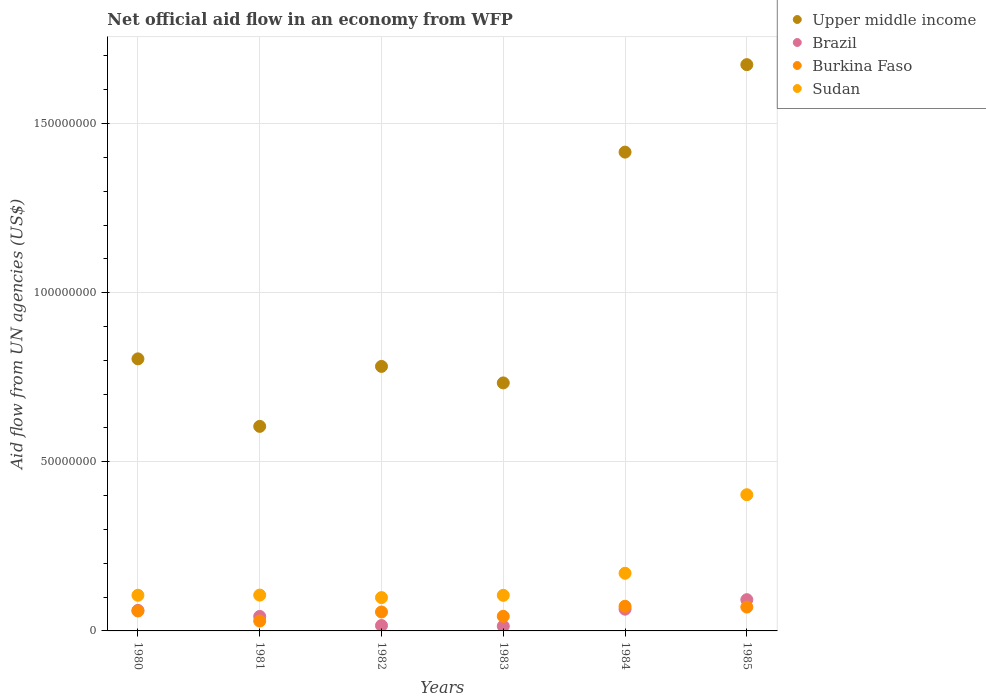How many different coloured dotlines are there?
Provide a short and direct response. 4. What is the net official aid flow in Burkina Faso in 1983?
Provide a short and direct response. 4.32e+06. Across all years, what is the maximum net official aid flow in Brazil?
Give a very brief answer. 9.24e+06. Across all years, what is the minimum net official aid flow in Upper middle income?
Your answer should be compact. 6.05e+07. In which year was the net official aid flow in Sudan maximum?
Your answer should be compact. 1985. In which year was the net official aid flow in Sudan minimum?
Offer a terse response. 1982. What is the total net official aid flow in Brazil in the graph?
Ensure brevity in your answer.  2.90e+07. What is the difference between the net official aid flow in Brazil in 1983 and that in 1984?
Provide a short and direct response. -5.03e+06. What is the difference between the net official aid flow in Burkina Faso in 1983 and the net official aid flow in Sudan in 1982?
Your response must be concise. -5.53e+06. What is the average net official aid flow in Upper middle income per year?
Make the answer very short. 1.00e+08. In the year 1985, what is the difference between the net official aid flow in Sudan and net official aid flow in Upper middle income?
Make the answer very short. -1.27e+08. In how many years, is the net official aid flow in Upper middle income greater than 30000000 US$?
Your response must be concise. 6. What is the ratio of the net official aid flow in Burkina Faso in 1981 to that in 1982?
Make the answer very short. 0.52. Is the net official aid flow in Upper middle income in 1983 less than that in 1984?
Offer a very short reply. Yes. What is the difference between the highest and the second highest net official aid flow in Upper middle income?
Offer a very short reply. 2.59e+07. What is the difference between the highest and the lowest net official aid flow in Brazil?
Your answer should be very brief. 7.84e+06. In how many years, is the net official aid flow in Upper middle income greater than the average net official aid flow in Upper middle income taken over all years?
Offer a very short reply. 2. How many dotlines are there?
Your answer should be very brief. 4. Are the values on the major ticks of Y-axis written in scientific E-notation?
Provide a succinct answer. No. Does the graph contain grids?
Make the answer very short. Yes. Where does the legend appear in the graph?
Offer a terse response. Top right. How many legend labels are there?
Give a very brief answer. 4. What is the title of the graph?
Keep it short and to the point. Net official aid flow in an economy from WFP. What is the label or title of the Y-axis?
Ensure brevity in your answer.  Aid flow from UN agencies (US$). What is the Aid flow from UN agencies (US$) in Upper middle income in 1980?
Your answer should be very brief. 8.04e+07. What is the Aid flow from UN agencies (US$) in Brazil in 1980?
Make the answer very short. 6.06e+06. What is the Aid flow from UN agencies (US$) in Burkina Faso in 1980?
Your answer should be very brief. 5.90e+06. What is the Aid flow from UN agencies (US$) of Sudan in 1980?
Offer a terse response. 1.05e+07. What is the Aid flow from UN agencies (US$) of Upper middle income in 1981?
Provide a short and direct response. 6.05e+07. What is the Aid flow from UN agencies (US$) in Brazil in 1981?
Ensure brevity in your answer.  4.28e+06. What is the Aid flow from UN agencies (US$) in Burkina Faso in 1981?
Provide a succinct answer. 2.92e+06. What is the Aid flow from UN agencies (US$) of Sudan in 1981?
Your answer should be very brief. 1.06e+07. What is the Aid flow from UN agencies (US$) in Upper middle income in 1982?
Make the answer very short. 7.82e+07. What is the Aid flow from UN agencies (US$) in Brazil in 1982?
Make the answer very short. 1.59e+06. What is the Aid flow from UN agencies (US$) of Burkina Faso in 1982?
Your answer should be compact. 5.60e+06. What is the Aid flow from UN agencies (US$) in Sudan in 1982?
Ensure brevity in your answer.  9.85e+06. What is the Aid flow from UN agencies (US$) of Upper middle income in 1983?
Your response must be concise. 7.33e+07. What is the Aid flow from UN agencies (US$) in Brazil in 1983?
Provide a short and direct response. 1.40e+06. What is the Aid flow from UN agencies (US$) in Burkina Faso in 1983?
Provide a short and direct response. 4.32e+06. What is the Aid flow from UN agencies (US$) of Sudan in 1983?
Provide a short and direct response. 1.05e+07. What is the Aid flow from UN agencies (US$) of Upper middle income in 1984?
Give a very brief answer. 1.42e+08. What is the Aid flow from UN agencies (US$) of Brazil in 1984?
Give a very brief answer. 6.43e+06. What is the Aid flow from UN agencies (US$) of Burkina Faso in 1984?
Offer a very short reply. 7.29e+06. What is the Aid flow from UN agencies (US$) of Sudan in 1984?
Your answer should be very brief. 1.70e+07. What is the Aid flow from UN agencies (US$) in Upper middle income in 1985?
Make the answer very short. 1.67e+08. What is the Aid flow from UN agencies (US$) in Brazil in 1985?
Offer a terse response. 9.24e+06. What is the Aid flow from UN agencies (US$) of Burkina Faso in 1985?
Offer a very short reply. 7.06e+06. What is the Aid flow from UN agencies (US$) of Sudan in 1985?
Your answer should be very brief. 4.03e+07. Across all years, what is the maximum Aid flow from UN agencies (US$) of Upper middle income?
Make the answer very short. 1.67e+08. Across all years, what is the maximum Aid flow from UN agencies (US$) of Brazil?
Your answer should be compact. 9.24e+06. Across all years, what is the maximum Aid flow from UN agencies (US$) in Burkina Faso?
Your response must be concise. 7.29e+06. Across all years, what is the maximum Aid flow from UN agencies (US$) of Sudan?
Provide a short and direct response. 4.03e+07. Across all years, what is the minimum Aid flow from UN agencies (US$) of Upper middle income?
Give a very brief answer. 6.05e+07. Across all years, what is the minimum Aid flow from UN agencies (US$) of Brazil?
Provide a short and direct response. 1.40e+06. Across all years, what is the minimum Aid flow from UN agencies (US$) of Burkina Faso?
Offer a terse response. 2.92e+06. Across all years, what is the minimum Aid flow from UN agencies (US$) in Sudan?
Your response must be concise. 9.85e+06. What is the total Aid flow from UN agencies (US$) in Upper middle income in the graph?
Your answer should be compact. 6.01e+08. What is the total Aid flow from UN agencies (US$) in Brazil in the graph?
Your response must be concise. 2.90e+07. What is the total Aid flow from UN agencies (US$) in Burkina Faso in the graph?
Your answer should be compact. 3.31e+07. What is the total Aid flow from UN agencies (US$) in Sudan in the graph?
Make the answer very short. 9.88e+07. What is the difference between the Aid flow from UN agencies (US$) in Upper middle income in 1980 and that in 1981?
Make the answer very short. 2.00e+07. What is the difference between the Aid flow from UN agencies (US$) in Brazil in 1980 and that in 1981?
Keep it short and to the point. 1.78e+06. What is the difference between the Aid flow from UN agencies (US$) of Burkina Faso in 1980 and that in 1981?
Provide a succinct answer. 2.98e+06. What is the difference between the Aid flow from UN agencies (US$) in Sudan in 1980 and that in 1981?
Your answer should be very brief. -5.00e+04. What is the difference between the Aid flow from UN agencies (US$) in Upper middle income in 1980 and that in 1982?
Keep it short and to the point. 2.23e+06. What is the difference between the Aid flow from UN agencies (US$) of Brazil in 1980 and that in 1982?
Give a very brief answer. 4.47e+06. What is the difference between the Aid flow from UN agencies (US$) of Sudan in 1980 and that in 1982?
Provide a short and direct response. 6.90e+05. What is the difference between the Aid flow from UN agencies (US$) in Upper middle income in 1980 and that in 1983?
Keep it short and to the point. 7.11e+06. What is the difference between the Aid flow from UN agencies (US$) in Brazil in 1980 and that in 1983?
Offer a terse response. 4.66e+06. What is the difference between the Aid flow from UN agencies (US$) of Burkina Faso in 1980 and that in 1983?
Give a very brief answer. 1.58e+06. What is the difference between the Aid flow from UN agencies (US$) in Sudan in 1980 and that in 1983?
Your answer should be compact. 2.00e+04. What is the difference between the Aid flow from UN agencies (US$) of Upper middle income in 1980 and that in 1984?
Your answer should be very brief. -6.11e+07. What is the difference between the Aid flow from UN agencies (US$) of Brazil in 1980 and that in 1984?
Keep it short and to the point. -3.70e+05. What is the difference between the Aid flow from UN agencies (US$) of Burkina Faso in 1980 and that in 1984?
Keep it short and to the point. -1.39e+06. What is the difference between the Aid flow from UN agencies (US$) of Sudan in 1980 and that in 1984?
Your answer should be compact. -6.51e+06. What is the difference between the Aid flow from UN agencies (US$) of Upper middle income in 1980 and that in 1985?
Ensure brevity in your answer.  -8.70e+07. What is the difference between the Aid flow from UN agencies (US$) of Brazil in 1980 and that in 1985?
Provide a succinct answer. -3.18e+06. What is the difference between the Aid flow from UN agencies (US$) in Burkina Faso in 1980 and that in 1985?
Your response must be concise. -1.16e+06. What is the difference between the Aid flow from UN agencies (US$) of Sudan in 1980 and that in 1985?
Provide a short and direct response. -2.97e+07. What is the difference between the Aid flow from UN agencies (US$) in Upper middle income in 1981 and that in 1982?
Your answer should be compact. -1.77e+07. What is the difference between the Aid flow from UN agencies (US$) of Brazil in 1981 and that in 1982?
Your answer should be very brief. 2.69e+06. What is the difference between the Aid flow from UN agencies (US$) of Burkina Faso in 1981 and that in 1982?
Offer a very short reply. -2.68e+06. What is the difference between the Aid flow from UN agencies (US$) in Sudan in 1981 and that in 1982?
Offer a terse response. 7.40e+05. What is the difference between the Aid flow from UN agencies (US$) of Upper middle income in 1981 and that in 1983?
Provide a short and direct response. -1.28e+07. What is the difference between the Aid flow from UN agencies (US$) of Brazil in 1981 and that in 1983?
Your answer should be compact. 2.88e+06. What is the difference between the Aid flow from UN agencies (US$) in Burkina Faso in 1981 and that in 1983?
Ensure brevity in your answer.  -1.40e+06. What is the difference between the Aid flow from UN agencies (US$) of Sudan in 1981 and that in 1983?
Your response must be concise. 7.00e+04. What is the difference between the Aid flow from UN agencies (US$) of Upper middle income in 1981 and that in 1984?
Offer a very short reply. -8.11e+07. What is the difference between the Aid flow from UN agencies (US$) in Brazil in 1981 and that in 1984?
Your answer should be very brief. -2.15e+06. What is the difference between the Aid flow from UN agencies (US$) in Burkina Faso in 1981 and that in 1984?
Provide a succinct answer. -4.37e+06. What is the difference between the Aid flow from UN agencies (US$) in Sudan in 1981 and that in 1984?
Your answer should be compact. -6.46e+06. What is the difference between the Aid flow from UN agencies (US$) of Upper middle income in 1981 and that in 1985?
Make the answer very short. -1.07e+08. What is the difference between the Aid flow from UN agencies (US$) in Brazil in 1981 and that in 1985?
Give a very brief answer. -4.96e+06. What is the difference between the Aid flow from UN agencies (US$) in Burkina Faso in 1981 and that in 1985?
Make the answer very short. -4.14e+06. What is the difference between the Aid flow from UN agencies (US$) in Sudan in 1981 and that in 1985?
Give a very brief answer. -2.97e+07. What is the difference between the Aid flow from UN agencies (US$) in Upper middle income in 1982 and that in 1983?
Provide a short and direct response. 4.88e+06. What is the difference between the Aid flow from UN agencies (US$) in Burkina Faso in 1982 and that in 1983?
Provide a succinct answer. 1.28e+06. What is the difference between the Aid flow from UN agencies (US$) in Sudan in 1982 and that in 1983?
Provide a short and direct response. -6.70e+05. What is the difference between the Aid flow from UN agencies (US$) of Upper middle income in 1982 and that in 1984?
Ensure brevity in your answer.  -6.34e+07. What is the difference between the Aid flow from UN agencies (US$) in Brazil in 1982 and that in 1984?
Provide a short and direct response. -4.84e+06. What is the difference between the Aid flow from UN agencies (US$) of Burkina Faso in 1982 and that in 1984?
Your answer should be compact. -1.69e+06. What is the difference between the Aid flow from UN agencies (US$) in Sudan in 1982 and that in 1984?
Ensure brevity in your answer.  -7.20e+06. What is the difference between the Aid flow from UN agencies (US$) in Upper middle income in 1982 and that in 1985?
Provide a succinct answer. -8.92e+07. What is the difference between the Aid flow from UN agencies (US$) of Brazil in 1982 and that in 1985?
Your answer should be very brief. -7.65e+06. What is the difference between the Aid flow from UN agencies (US$) of Burkina Faso in 1982 and that in 1985?
Provide a short and direct response. -1.46e+06. What is the difference between the Aid flow from UN agencies (US$) of Sudan in 1982 and that in 1985?
Your answer should be compact. -3.04e+07. What is the difference between the Aid flow from UN agencies (US$) in Upper middle income in 1983 and that in 1984?
Keep it short and to the point. -6.82e+07. What is the difference between the Aid flow from UN agencies (US$) in Brazil in 1983 and that in 1984?
Offer a very short reply. -5.03e+06. What is the difference between the Aid flow from UN agencies (US$) in Burkina Faso in 1983 and that in 1984?
Offer a terse response. -2.97e+06. What is the difference between the Aid flow from UN agencies (US$) in Sudan in 1983 and that in 1984?
Ensure brevity in your answer.  -6.53e+06. What is the difference between the Aid flow from UN agencies (US$) of Upper middle income in 1983 and that in 1985?
Give a very brief answer. -9.41e+07. What is the difference between the Aid flow from UN agencies (US$) in Brazil in 1983 and that in 1985?
Offer a very short reply. -7.84e+06. What is the difference between the Aid flow from UN agencies (US$) in Burkina Faso in 1983 and that in 1985?
Your answer should be compact. -2.74e+06. What is the difference between the Aid flow from UN agencies (US$) in Sudan in 1983 and that in 1985?
Keep it short and to the point. -2.98e+07. What is the difference between the Aid flow from UN agencies (US$) in Upper middle income in 1984 and that in 1985?
Provide a short and direct response. -2.59e+07. What is the difference between the Aid flow from UN agencies (US$) of Brazil in 1984 and that in 1985?
Offer a terse response. -2.81e+06. What is the difference between the Aid flow from UN agencies (US$) in Burkina Faso in 1984 and that in 1985?
Offer a very short reply. 2.30e+05. What is the difference between the Aid flow from UN agencies (US$) in Sudan in 1984 and that in 1985?
Keep it short and to the point. -2.32e+07. What is the difference between the Aid flow from UN agencies (US$) of Upper middle income in 1980 and the Aid flow from UN agencies (US$) of Brazil in 1981?
Provide a short and direct response. 7.62e+07. What is the difference between the Aid flow from UN agencies (US$) in Upper middle income in 1980 and the Aid flow from UN agencies (US$) in Burkina Faso in 1981?
Your response must be concise. 7.75e+07. What is the difference between the Aid flow from UN agencies (US$) of Upper middle income in 1980 and the Aid flow from UN agencies (US$) of Sudan in 1981?
Ensure brevity in your answer.  6.98e+07. What is the difference between the Aid flow from UN agencies (US$) of Brazil in 1980 and the Aid flow from UN agencies (US$) of Burkina Faso in 1981?
Your answer should be compact. 3.14e+06. What is the difference between the Aid flow from UN agencies (US$) in Brazil in 1980 and the Aid flow from UN agencies (US$) in Sudan in 1981?
Your answer should be compact. -4.53e+06. What is the difference between the Aid flow from UN agencies (US$) in Burkina Faso in 1980 and the Aid flow from UN agencies (US$) in Sudan in 1981?
Your answer should be compact. -4.69e+06. What is the difference between the Aid flow from UN agencies (US$) in Upper middle income in 1980 and the Aid flow from UN agencies (US$) in Brazil in 1982?
Offer a terse response. 7.88e+07. What is the difference between the Aid flow from UN agencies (US$) of Upper middle income in 1980 and the Aid flow from UN agencies (US$) of Burkina Faso in 1982?
Give a very brief answer. 7.48e+07. What is the difference between the Aid flow from UN agencies (US$) in Upper middle income in 1980 and the Aid flow from UN agencies (US$) in Sudan in 1982?
Make the answer very short. 7.06e+07. What is the difference between the Aid flow from UN agencies (US$) of Brazil in 1980 and the Aid flow from UN agencies (US$) of Sudan in 1982?
Your response must be concise. -3.79e+06. What is the difference between the Aid flow from UN agencies (US$) of Burkina Faso in 1980 and the Aid flow from UN agencies (US$) of Sudan in 1982?
Your answer should be very brief. -3.95e+06. What is the difference between the Aid flow from UN agencies (US$) of Upper middle income in 1980 and the Aid flow from UN agencies (US$) of Brazil in 1983?
Your answer should be compact. 7.90e+07. What is the difference between the Aid flow from UN agencies (US$) in Upper middle income in 1980 and the Aid flow from UN agencies (US$) in Burkina Faso in 1983?
Provide a short and direct response. 7.61e+07. What is the difference between the Aid flow from UN agencies (US$) of Upper middle income in 1980 and the Aid flow from UN agencies (US$) of Sudan in 1983?
Your response must be concise. 6.99e+07. What is the difference between the Aid flow from UN agencies (US$) of Brazil in 1980 and the Aid flow from UN agencies (US$) of Burkina Faso in 1983?
Provide a succinct answer. 1.74e+06. What is the difference between the Aid flow from UN agencies (US$) in Brazil in 1980 and the Aid flow from UN agencies (US$) in Sudan in 1983?
Your answer should be very brief. -4.46e+06. What is the difference between the Aid flow from UN agencies (US$) in Burkina Faso in 1980 and the Aid flow from UN agencies (US$) in Sudan in 1983?
Make the answer very short. -4.62e+06. What is the difference between the Aid flow from UN agencies (US$) of Upper middle income in 1980 and the Aid flow from UN agencies (US$) of Brazil in 1984?
Offer a very short reply. 7.40e+07. What is the difference between the Aid flow from UN agencies (US$) in Upper middle income in 1980 and the Aid flow from UN agencies (US$) in Burkina Faso in 1984?
Make the answer very short. 7.32e+07. What is the difference between the Aid flow from UN agencies (US$) in Upper middle income in 1980 and the Aid flow from UN agencies (US$) in Sudan in 1984?
Keep it short and to the point. 6.34e+07. What is the difference between the Aid flow from UN agencies (US$) of Brazil in 1980 and the Aid flow from UN agencies (US$) of Burkina Faso in 1984?
Give a very brief answer. -1.23e+06. What is the difference between the Aid flow from UN agencies (US$) of Brazil in 1980 and the Aid flow from UN agencies (US$) of Sudan in 1984?
Provide a short and direct response. -1.10e+07. What is the difference between the Aid flow from UN agencies (US$) in Burkina Faso in 1980 and the Aid flow from UN agencies (US$) in Sudan in 1984?
Ensure brevity in your answer.  -1.12e+07. What is the difference between the Aid flow from UN agencies (US$) of Upper middle income in 1980 and the Aid flow from UN agencies (US$) of Brazil in 1985?
Your response must be concise. 7.12e+07. What is the difference between the Aid flow from UN agencies (US$) in Upper middle income in 1980 and the Aid flow from UN agencies (US$) in Burkina Faso in 1985?
Your response must be concise. 7.34e+07. What is the difference between the Aid flow from UN agencies (US$) of Upper middle income in 1980 and the Aid flow from UN agencies (US$) of Sudan in 1985?
Offer a very short reply. 4.02e+07. What is the difference between the Aid flow from UN agencies (US$) in Brazil in 1980 and the Aid flow from UN agencies (US$) in Sudan in 1985?
Ensure brevity in your answer.  -3.42e+07. What is the difference between the Aid flow from UN agencies (US$) of Burkina Faso in 1980 and the Aid flow from UN agencies (US$) of Sudan in 1985?
Your answer should be compact. -3.44e+07. What is the difference between the Aid flow from UN agencies (US$) of Upper middle income in 1981 and the Aid flow from UN agencies (US$) of Brazil in 1982?
Your answer should be compact. 5.89e+07. What is the difference between the Aid flow from UN agencies (US$) of Upper middle income in 1981 and the Aid flow from UN agencies (US$) of Burkina Faso in 1982?
Your response must be concise. 5.49e+07. What is the difference between the Aid flow from UN agencies (US$) in Upper middle income in 1981 and the Aid flow from UN agencies (US$) in Sudan in 1982?
Provide a succinct answer. 5.06e+07. What is the difference between the Aid flow from UN agencies (US$) in Brazil in 1981 and the Aid flow from UN agencies (US$) in Burkina Faso in 1982?
Offer a terse response. -1.32e+06. What is the difference between the Aid flow from UN agencies (US$) in Brazil in 1981 and the Aid flow from UN agencies (US$) in Sudan in 1982?
Your answer should be very brief. -5.57e+06. What is the difference between the Aid flow from UN agencies (US$) of Burkina Faso in 1981 and the Aid flow from UN agencies (US$) of Sudan in 1982?
Provide a succinct answer. -6.93e+06. What is the difference between the Aid flow from UN agencies (US$) of Upper middle income in 1981 and the Aid flow from UN agencies (US$) of Brazil in 1983?
Your answer should be compact. 5.91e+07. What is the difference between the Aid flow from UN agencies (US$) in Upper middle income in 1981 and the Aid flow from UN agencies (US$) in Burkina Faso in 1983?
Provide a succinct answer. 5.62e+07. What is the difference between the Aid flow from UN agencies (US$) in Upper middle income in 1981 and the Aid flow from UN agencies (US$) in Sudan in 1983?
Offer a terse response. 5.00e+07. What is the difference between the Aid flow from UN agencies (US$) of Brazil in 1981 and the Aid flow from UN agencies (US$) of Burkina Faso in 1983?
Offer a terse response. -4.00e+04. What is the difference between the Aid flow from UN agencies (US$) of Brazil in 1981 and the Aid flow from UN agencies (US$) of Sudan in 1983?
Ensure brevity in your answer.  -6.24e+06. What is the difference between the Aid flow from UN agencies (US$) of Burkina Faso in 1981 and the Aid flow from UN agencies (US$) of Sudan in 1983?
Keep it short and to the point. -7.60e+06. What is the difference between the Aid flow from UN agencies (US$) of Upper middle income in 1981 and the Aid flow from UN agencies (US$) of Brazil in 1984?
Make the answer very short. 5.40e+07. What is the difference between the Aid flow from UN agencies (US$) of Upper middle income in 1981 and the Aid flow from UN agencies (US$) of Burkina Faso in 1984?
Offer a very short reply. 5.32e+07. What is the difference between the Aid flow from UN agencies (US$) in Upper middle income in 1981 and the Aid flow from UN agencies (US$) in Sudan in 1984?
Ensure brevity in your answer.  4.34e+07. What is the difference between the Aid flow from UN agencies (US$) in Brazil in 1981 and the Aid flow from UN agencies (US$) in Burkina Faso in 1984?
Keep it short and to the point. -3.01e+06. What is the difference between the Aid flow from UN agencies (US$) of Brazil in 1981 and the Aid flow from UN agencies (US$) of Sudan in 1984?
Make the answer very short. -1.28e+07. What is the difference between the Aid flow from UN agencies (US$) of Burkina Faso in 1981 and the Aid flow from UN agencies (US$) of Sudan in 1984?
Offer a very short reply. -1.41e+07. What is the difference between the Aid flow from UN agencies (US$) of Upper middle income in 1981 and the Aid flow from UN agencies (US$) of Brazil in 1985?
Offer a very short reply. 5.12e+07. What is the difference between the Aid flow from UN agencies (US$) in Upper middle income in 1981 and the Aid flow from UN agencies (US$) in Burkina Faso in 1985?
Offer a very short reply. 5.34e+07. What is the difference between the Aid flow from UN agencies (US$) of Upper middle income in 1981 and the Aid flow from UN agencies (US$) of Sudan in 1985?
Give a very brief answer. 2.02e+07. What is the difference between the Aid flow from UN agencies (US$) in Brazil in 1981 and the Aid flow from UN agencies (US$) in Burkina Faso in 1985?
Your answer should be very brief. -2.78e+06. What is the difference between the Aid flow from UN agencies (US$) of Brazil in 1981 and the Aid flow from UN agencies (US$) of Sudan in 1985?
Offer a very short reply. -3.60e+07. What is the difference between the Aid flow from UN agencies (US$) of Burkina Faso in 1981 and the Aid flow from UN agencies (US$) of Sudan in 1985?
Provide a short and direct response. -3.74e+07. What is the difference between the Aid flow from UN agencies (US$) of Upper middle income in 1982 and the Aid flow from UN agencies (US$) of Brazil in 1983?
Offer a terse response. 7.68e+07. What is the difference between the Aid flow from UN agencies (US$) in Upper middle income in 1982 and the Aid flow from UN agencies (US$) in Burkina Faso in 1983?
Ensure brevity in your answer.  7.39e+07. What is the difference between the Aid flow from UN agencies (US$) in Upper middle income in 1982 and the Aid flow from UN agencies (US$) in Sudan in 1983?
Your answer should be very brief. 6.77e+07. What is the difference between the Aid flow from UN agencies (US$) in Brazil in 1982 and the Aid flow from UN agencies (US$) in Burkina Faso in 1983?
Ensure brevity in your answer.  -2.73e+06. What is the difference between the Aid flow from UN agencies (US$) in Brazil in 1982 and the Aid flow from UN agencies (US$) in Sudan in 1983?
Offer a terse response. -8.93e+06. What is the difference between the Aid flow from UN agencies (US$) in Burkina Faso in 1982 and the Aid flow from UN agencies (US$) in Sudan in 1983?
Ensure brevity in your answer.  -4.92e+06. What is the difference between the Aid flow from UN agencies (US$) in Upper middle income in 1982 and the Aid flow from UN agencies (US$) in Brazil in 1984?
Make the answer very short. 7.18e+07. What is the difference between the Aid flow from UN agencies (US$) in Upper middle income in 1982 and the Aid flow from UN agencies (US$) in Burkina Faso in 1984?
Provide a short and direct response. 7.09e+07. What is the difference between the Aid flow from UN agencies (US$) of Upper middle income in 1982 and the Aid flow from UN agencies (US$) of Sudan in 1984?
Your response must be concise. 6.12e+07. What is the difference between the Aid flow from UN agencies (US$) of Brazil in 1982 and the Aid flow from UN agencies (US$) of Burkina Faso in 1984?
Make the answer very short. -5.70e+06. What is the difference between the Aid flow from UN agencies (US$) of Brazil in 1982 and the Aid flow from UN agencies (US$) of Sudan in 1984?
Give a very brief answer. -1.55e+07. What is the difference between the Aid flow from UN agencies (US$) in Burkina Faso in 1982 and the Aid flow from UN agencies (US$) in Sudan in 1984?
Keep it short and to the point. -1.14e+07. What is the difference between the Aid flow from UN agencies (US$) in Upper middle income in 1982 and the Aid flow from UN agencies (US$) in Brazil in 1985?
Provide a short and direct response. 6.90e+07. What is the difference between the Aid flow from UN agencies (US$) in Upper middle income in 1982 and the Aid flow from UN agencies (US$) in Burkina Faso in 1985?
Your response must be concise. 7.12e+07. What is the difference between the Aid flow from UN agencies (US$) in Upper middle income in 1982 and the Aid flow from UN agencies (US$) in Sudan in 1985?
Offer a very short reply. 3.79e+07. What is the difference between the Aid flow from UN agencies (US$) in Brazil in 1982 and the Aid flow from UN agencies (US$) in Burkina Faso in 1985?
Provide a succinct answer. -5.47e+06. What is the difference between the Aid flow from UN agencies (US$) in Brazil in 1982 and the Aid flow from UN agencies (US$) in Sudan in 1985?
Keep it short and to the point. -3.87e+07. What is the difference between the Aid flow from UN agencies (US$) of Burkina Faso in 1982 and the Aid flow from UN agencies (US$) of Sudan in 1985?
Give a very brief answer. -3.47e+07. What is the difference between the Aid flow from UN agencies (US$) of Upper middle income in 1983 and the Aid flow from UN agencies (US$) of Brazil in 1984?
Provide a short and direct response. 6.69e+07. What is the difference between the Aid flow from UN agencies (US$) in Upper middle income in 1983 and the Aid flow from UN agencies (US$) in Burkina Faso in 1984?
Provide a short and direct response. 6.60e+07. What is the difference between the Aid flow from UN agencies (US$) in Upper middle income in 1983 and the Aid flow from UN agencies (US$) in Sudan in 1984?
Provide a short and direct response. 5.63e+07. What is the difference between the Aid flow from UN agencies (US$) of Brazil in 1983 and the Aid flow from UN agencies (US$) of Burkina Faso in 1984?
Your answer should be compact. -5.89e+06. What is the difference between the Aid flow from UN agencies (US$) of Brazil in 1983 and the Aid flow from UN agencies (US$) of Sudan in 1984?
Your answer should be compact. -1.56e+07. What is the difference between the Aid flow from UN agencies (US$) in Burkina Faso in 1983 and the Aid flow from UN agencies (US$) in Sudan in 1984?
Your answer should be compact. -1.27e+07. What is the difference between the Aid flow from UN agencies (US$) in Upper middle income in 1983 and the Aid flow from UN agencies (US$) in Brazil in 1985?
Offer a terse response. 6.41e+07. What is the difference between the Aid flow from UN agencies (US$) of Upper middle income in 1983 and the Aid flow from UN agencies (US$) of Burkina Faso in 1985?
Ensure brevity in your answer.  6.63e+07. What is the difference between the Aid flow from UN agencies (US$) of Upper middle income in 1983 and the Aid flow from UN agencies (US$) of Sudan in 1985?
Ensure brevity in your answer.  3.31e+07. What is the difference between the Aid flow from UN agencies (US$) of Brazil in 1983 and the Aid flow from UN agencies (US$) of Burkina Faso in 1985?
Your response must be concise. -5.66e+06. What is the difference between the Aid flow from UN agencies (US$) in Brazil in 1983 and the Aid flow from UN agencies (US$) in Sudan in 1985?
Provide a short and direct response. -3.89e+07. What is the difference between the Aid flow from UN agencies (US$) in Burkina Faso in 1983 and the Aid flow from UN agencies (US$) in Sudan in 1985?
Provide a succinct answer. -3.60e+07. What is the difference between the Aid flow from UN agencies (US$) in Upper middle income in 1984 and the Aid flow from UN agencies (US$) in Brazil in 1985?
Ensure brevity in your answer.  1.32e+08. What is the difference between the Aid flow from UN agencies (US$) of Upper middle income in 1984 and the Aid flow from UN agencies (US$) of Burkina Faso in 1985?
Offer a terse response. 1.35e+08. What is the difference between the Aid flow from UN agencies (US$) of Upper middle income in 1984 and the Aid flow from UN agencies (US$) of Sudan in 1985?
Your answer should be very brief. 1.01e+08. What is the difference between the Aid flow from UN agencies (US$) in Brazil in 1984 and the Aid flow from UN agencies (US$) in Burkina Faso in 1985?
Offer a terse response. -6.30e+05. What is the difference between the Aid flow from UN agencies (US$) in Brazil in 1984 and the Aid flow from UN agencies (US$) in Sudan in 1985?
Provide a succinct answer. -3.38e+07. What is the difference between the Aid flow from UN agencies (US$) in Burkina Faso in 1984 and the Aid flow from UN agencies (US$) in Sudan in 1985?
Your response must be concise. -3.30e+07. What is the average Aid flow from UN agencies (US$) of Upper middle income per year?
Offer a very short reply. 1.00e+08. What is the average Aid flow from UN agencies (US$) of Brazil per year?
Make the answer very short. 4.83e+06. What is the average Aid flow from UN agencies (US$) in Burkina Faso per year?
Provide a succinct answer. 5.52e+06. What is the average Aid flow from UN agencies (US$) in Sudan per year?
Keep it short and to the point. 1.65e+07. In the year 1980, what is the difference between the Aid flow from UN agencies (US$) in Upper middle income and Aid flow from UN agencies (US$) in Brazil?
Provide a succinct answer. 7.44e+07. In the year 1980, what is the difference between the Aid flow from UN agencies (US$) of Upper middle income and Aid flow from UN agencies (US$) of Burkina Faso?
Provide a short and direct response. 7.45e+07. In the year 1980, what is the difference between the Aid flow from UN agencies (US$) of Upper middle income and Aid flow from UN agencies (US$) of Sudan?
Your response must be concise. 6.99e+07. In the year 1980, what is the difference between the Aid flow from UN agencies (US$) of Brazil and Aid flow from UN agencies (US$) of Burkina Faso?
Your response must be concise. 1.60e+05. In the year 1980, what is the difference between the Aid flow from UN agencies (US$) of Brazil and Aid flow from UN agencies (US$) of Sudan?
Your answer should be compact. -4.48e+06. In the year 1980, what is the difference between the Aid flow from UN agencies (US$) in Burkina Faso and Aid flow from UN agencies (US$) in Sudan?
Provide a succinct answer. -4.64e+06. In the year 1981, what is the difference between the Aid flow from UN agencies (US$) of Upper middle income and Aid flow from UN agencies (US$) of Brazil?
Offer a very short reply. 5.62e+07. In the year 1981, what is the difference between the Aid flow from UN agencies (US$) of Upper middle income and Aid flow from UN agencies (US$) of Burkina Faso?
Offer a terse response. 5.76e+07. In the year 1981, what is the difference between the Aid flow from UN agencies (US$) in Upper middle income and Aid flow from UN agencies (US$) in Sudan?
Your response must be concise. 4.99e+07. In the year 1981, what is the difference between the Aid flow from UN agencies (US$) of Brazil and Aid flow from UN agencies (US$) of Burkina Faso?
Ensure brevity in your answer.  1.36e+06. In the year 1981, what is the difference between the Aid flow from UN agencies (US$) of Brazil and Aid flow from UN agencies (US$) of Sudan?
Keep it short and to the point. -6.31e+06. In the year 1981, what is the difference between the Aid flow from UN agencies (US$) in Burkina Faso and Aid flow from UN agencies (US$) in Sudan?
Offer a terse response. -7.67e+06. In the year 1982, what is the difference between the Aid flow from UN agencies (US$) in Upper middle income and Aid flow from UN agencies (US$) in Brazil?
Make the answer very short. 7.66e+07. In the year 1982, what is the difference between the Aid flow from UN agencies (US$) of Upper middle income and Aid flow from UN agencies (US$) of Burkina Faso?
Your answer should be compact. 7.26e+07. In the year 1982, what is the difference between the Aid flow from UN agencies (US$) in Upper middle income and Aid flow from UN agencies (US$) in Sudan?
Provide a succinct answer. 6.84e+07. In the year 1982, what is the difference between the Aid flow from UN agencies (US$) in Brazil and Aid flow from UN agencies (US$) in Burkina Faso?
Offer a terse response. -4.01e+06. In the year 1982, what is the difference between the Aid flow from UN agencies (US$) in Brazil and Aid flow from UN agencies (US$) in Sudan?
Offer a very short reply. -8.26e+06. In the year 1982, what is the difference between the Aid flow from UN agencies (US$) in Burkina Faso and Aid flow from UN agencies (US$) in Sudan?
Ensure brevity in your answer.  -4.25e+06. In the year 1983, what is the difference between the Aid flow from UN agencies (US$) of Upper middle income and Aid flow from UN agencies (US$) of Brazil?
Give a very brief answer. 7.19e+07. In the year 1983, what is the difference between the Aid flow from UN agencies (US$) of Upper middle income and Aid flow from UN agencies (US$) of Burkina Faso?
Give a very brief answer. 6.90e+07. In the year 1983, what is the difference between the Aid flow from UN agencies (US$) in Upper middle income and Aid flow from UN agencies (US$) in Sudan?
Give a very brief answer. 6.28e+07. In the year 1983, what is the difference between the Aid flow from UN agencies (US$) of Brazil and Aid flow from UN agencies (US$) of Burkina Faso?
Your response must be concise. -2.92e+06. In the year 1983, what is the difference between the Aid flow from UN agencies (US$) in Brazil and Aid flow from UN agencies (US$) in Sudan?
Offer a terse response. -9.12e+06. In the year 1983, what is the difference between the Aid flow from UN agencies (US$) of Burkina Faso and Aid flow from UN agencies (US$) of Sudan?
Provide a short and direct response. -6.20e+06. In the year 1984, what is the difference between the Aid flow from UN agencies (US$) in Upper middle income and Aid flow from UN agencies (US$) in Brazil?
Provide a succinct answer. 1.35e+08. In the year 1984, what is the difference between the Aid flow from UN agencies (US$) of Upper middle income and Aid flow from UN agencies (US$) of Burkina Faso?
Provide a short and direct response. 1.34e+08. In the year 1984, what is the difference between the Aid flow from UN agencies (US$) in Upper middle income and Aid flow from UN agencies (US$) in Sudan?
Offer a terse response. 1.25e+08. In the year 1984, what is the difference between the Aid flow from UN agencies (US$) of Brazil and Aid flow from UN agencies (US$) of Burkina Faso?
Your response must be concise. -8.60e+05. In the year 1984, what is the difference between the Aid flow from UN agencies (US$) of Brazil and Aid flow from UN agencies (US$) of Sudan?
Offer a terse response. -1.06e+07. In the year 1984, what is the difference between the Aid flow from UN agencies (US$) in Burkina Faso and Aid flow from UN agencies (US$) in Sudan?
Your answer should be very brief. -9.76e+06. In the year 1985, what is the difference between the Aid flow from UN agencies (US$) in Upper middle income and Aid flow from UN agencies (US$) in Brazil?
Give a very brief answer. 1.58e+08. In the year 1985, what is the difference between the Aid flow from UN agencies (US$) in Upper middle income and Aid flow from UN agencies (US$) in Burkina Faso?
Keep it short and to the point. 1.60e+08. In the year 1985, what is the difference between the Aid flow from UN agencies (US$) in Upper middle income and Aid flow from UN agencies (US$) in Sudan?
Your answer should be compact. 1.27e+08. In the year 1985, what is the difference between the Aid flow from UN agencies (US$) of Brazil and Aid flow from UN agencies (US$) of Burkina Faso?
Keep it short and to the point. 2.18e+06. In the year 1985, what is the difference between the Aid flow from UN agencies (US$) in Brazil and Aid flow from UN agencies (US$) in Sudan?
Offer a very short reply. -3.10e+07. In the year 1985, what is the difference between the Aid flow from UN agencies (US$) in Burkina Faso and Aid flow from UN agencies (US$) in Sudan?
Make the answer very short. -3.32e+07. What is the ratio of the Aid flow from UN agencies (US$) of Upper middle income in 1980 to that in 1981?
Your answer should be very brief. 1.33. What is the ratio of the Aid flow from UN agencies (US$) of Brazil in 1980 to that in 1981?
Give a very brief answer. 1.42. What is the ratio of the Aid flow from UN agencies (US$) of Burkina Faso in 1980 to that in 1981?
Keep it short and to the point. 2.02. What is the ratio of the Aid flow from UN agencies (US$) in Sudan in 1980 to that in 1981?
Offer a terse response. 1. What is the ratio of the Aid flow from UN agencies (US$) of Upper middle income in 1980 to that in 1982?
Keep it short and to the point. 1.03. What is the ratio of the Aid flow from UN agencies (US$) in Brazil in 1980 to that in 1982?
Your answer should be very brief. 3.81. What is the ratio of the Aid flow from UN agencies (US$) of Burkina Faso in 1980 to that in 1982?
Keep it short and to the point. 1.05. What is the ratio of the Aid flow from UN agencies (US$) of Sudan in 1980 to that in 1982?
Ensure brevity in your answer.  1.07. What is the ratio of the Aid flow from UN agencies (US$) in Upper middle income in 1980 to that in 1983?
Offer a terse response. 1.1. What is the ratio of the Aid flow from UN agencies (US$) in Brazil in 1980 to that in 1983?
Your answer should be very brief. 4.33. What is the ratio of the Aid flow from UN agencies (US$) of Burkina Faso in 1980 to that in 1983?
Offer a very short reply. 1.37. What is the ratio of the Aid flow from UN agencies (US$) in Upper middle income in 1980 to that in 1984?
Ensure brevity in your answer.  0.57. What is the ratio of the Aid flow from UN agencies (US$) of Brazil in 1980 to that in 1984?
Give a very brief answer. 0.94. What is the ratio of the Aid flow from UN agencies (US$) of Burkina Faso in 1980 to that in 1984?
Your response must be concise. 0.81. What is the ratio of the Aid flow from UN agencies (US$) of Sudan in 1980 to that in 1984?
Give a very brief answer. 0.62. What is the ratio of the Aid flow from UN agencies (US$) in Upper middle income in 1980 to that in 1985?
Provide a succinct answer. 0.48. What is the ratio of the Aid flow from UN agencies (US$) in Brazil in 1980 to that in 1985?
Keep it short and to the point. 0.66. What is the ratio of the Aid flow from UN agencies (US$) of Burkina Faso in 1980 to that in 1985?
Your response must be concise. 0.84. What is the ratio of the Aid flow from UN agencies (US$) of Sudan in 1980 to that in 1985?
Your response must be concise. 0.26. What is the ratio of the Aid flow from UN agencies (US$) of Upper middle income in 1981 to that in 1982?
Offer a terse response. 0.77. What is the ratio of the Aid flow from UN agencies (US$) of Brazil in 1981 to that in 1982?
Your response must be concise. 2.69. What is the ratio of the Aid flow from UN agencies (US$) in Burkina Faso in 1981 to that in 1982?
Keep it short and to the point. 0.52. What is the ratio of the Aid flow from UN agencies (US$) of Sudan in 1981 to that in 1982?
Keep it short and to the point. 1.08. What is the ratio of the Aid flow from UN agencies (US$) in Upper middle income in 1981 to that in 1983?
Your answer should be compact. 0.82. What is the ratio of the Aid flow from UN agencies (US$) of Brazil in 1981 to that in 1983?
Provide a succinct answer. 3.06. What is the ratio of the Aid flow from UN agencies (US$) in Burkina Faso in 1981 to that in 1983?
Your response must be concise. 0.68. What is the ratio of the Aid flow from UN agencies (US$) of Upper middle income in 1981 to that in 1984?
Your answer should be compact. 0.43. What is the ratio of the Aid flow from UN agencies (US$) in Brazil in 1981 to that in 1984?
Your answer should be compact. 0.67. What is the ratio of the Aid flow from UN agencies (US$) in Burkina Faso in 1981 to that in 1984?
Make the answer very short. 0.4. What is the ratio of the Aid flow from UN agencies (US$) of Sudan in 1981 to that in 1984?
Your answer should be very brief. 0.62. What is the ratio of the Aid flow from UN agencies (US$) of Upper middle income in 1981 to that in 1985?
Make the answer very short. 0.36. What is the ratio of the Aid flow from UN agencies (US$) of Brazil in 1981 to that in 1985?
Ensure brevity in your answer.  0.46. What is the ratio of the Aid flow from UN agencies (US$) of Burkina Faso in 1981 to that in 1985?
Your answer should be very brief. 0.41. What is the ratio of the Aid flow from UN agencies (US$) in Sudan in 1981 to that in 1985?
Offer a very short reply. 0.26. What is the ratio of the Aid flow from UN agencies (US$) of Upper middle income in 1982 to that in 1983?
Offer a terse response. 1.07. What is the ratio of the Aid flow from UN agencies (US$) of Brazil in 1982 to that in 1983?
Your answer should be compact. 1.14. What is the ratio of the Aid flow from UN agencies (US$) in Burkina Faso in 1982 to that in 1983?
Provide a succinct answer. 1.3. What is the ratio of the Aid flow from UN agencies (US$) in Sudan in 1982 to that in 1983?
Keep it short and to the point. 0.94. What is the ratio of the Aid flow from UN agencies (US$) of Upper middle income in 1982 to that in 1984?
Your answer should be compact. 0.55. What is the ratio of the Aid flow from UN agencies (US$) in Brazil in 1982 to that in 1984?
Offer a terse response. 0.25. What is the ratio of the Aid flow from UN agencies (US$) in Burkina Faso in 1982 to that in 1984?
Your response must be concise. 0.77. What is the ratio of the Aid flow from UN agencies (US$) of Sudan in 1982 to that in 1984?
Your answer should be very brief. 0.58. What is the ratio of the Aid flow from UN agencies (US$) in Upper middle income in 1982 to that in 1985?
Offer a very short reply. 0.47. What is the ratio of the Aid flow from UN agencies (US$) of Brazil in 1982 to that in 1985?
Your answer should be very brief. 0.17. What is the ratio of the Aid flow from UN agencies (US$) of Burkina Faso in 1982 to that in 1985?
Ensure brevity in your answer.  0.79. What is the ratio of the Aid flow from UN agencies (US$) in Sudan in 1982 to that in 1985?
Offer a very short reply. 0.24. What is the ratio of the Aid flow from UN agencies (US$) in Upper middle income in 1983 to that in 1984?
Your answer should be compact. 0.52. What is the ratio of the Aid flow from UN agencies (US$) of Brazil in 1983 to that in 1984?
Offer a terse response. 0.22. What is the ratio of the Aid flow from UN agencies (US$) of Burkina Faso in 1983 to that in 1984?
Provide a short and direct response. 0.59. What is the ratio of the Aid flow from UN agencies (US$) of Sudan in 1983 to that in 1984?
Make the answer very short. 0.62. What is the ratio of the Aid flow from UN agencies (US$) of Upper middle income in 1983 to that in 1985?
Offer a very short reply. 0.44. What is the ratio of the Aid flow from UN agencies (US$) of Brazil in 1983 to that in 1985?
Offer a terse response. 0.15. What is the ratio of the Aid flow from UN agencies (US$) in Burkina Faso in 1983 to that in 1985?
Offer a very short reply. 0.61. What is the ratio of the Aid flow from UN agencies (US$) of Sudan in 1983 to that in 1985?
Your response must be concise. 0.26. What is the ratio of the Aid flow from UN agencies (US$) of Upper middle income in 1984 to that in 1985?
Make the answer very short. 0.85. What is the ratio of the Aid flow from UN agencies (US$) of Brazil in 1984 to that in 1985?
Provide a succinct answer. 0.7. What is the ratio of the Aid flow from UN agencies (US$) of Burkina Faso in 1984 to that in 1985?
Your answer should be compact. 1.03. What is the ratio of the Aid flow from UN agencies (US$) of Sudan in 1984 to that in 1985?
Ensure brevity in your answer.  0.42. What is the difference between the highest and the second highest Aid flow from UN agencies (US$) of Upper middle income?
Offer a terse response. 2.59e+07. What is the difference between the highest and the second highest Aid flow from UN agencies (US$) of Brazil?
Provide a short and direct response. 2.81e+06. What is the difference between the highest and the second highest Aid flow from UN agencies (US$) in Sudan?
Your answer should be very brief. 2.32e+07. What is the difference between the highest and the lowest Aid flow from UN agencies (US$) of Upper middle income?
Your answer should be very brief. 1.07e+08. What is the difference between the highest and the lowest Aid flow from UN agencies (US$) in Brazil?
Your answer should be compact. 7.84e+06. What is the difference between the highest and the lowest Aid flow from UN agencies (US$) of Burkina Faso?
Offer a terse response. 4.37e+06. What is the difference between the highest and the lowest Aid flow from UN agencies (US$) in Sudan?
Offer a terse response. 3.04e+07. 